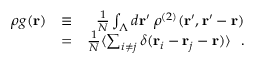Convert formula to latex. <formula><loc_0><loc_0><loc_500><loc_500>\begin{array} { r l r } { \rho g ( { r } ) } & { \equiv } & { \frac { 1 } { N } \int _ { \Lambda } d { r } ^ { \prime } \, \rho ^ { ( 2 ) } ( { r } ^ { \prime } , { r } ^ { \prime } - { r } ) } \\ & { = } & { \frac { 1 } { N } \langle \sum _ { i \neq j } \delta ( { r } _ { i } - { r } _ { j } - { r } ) \rangle . } \end{array}</formula> 